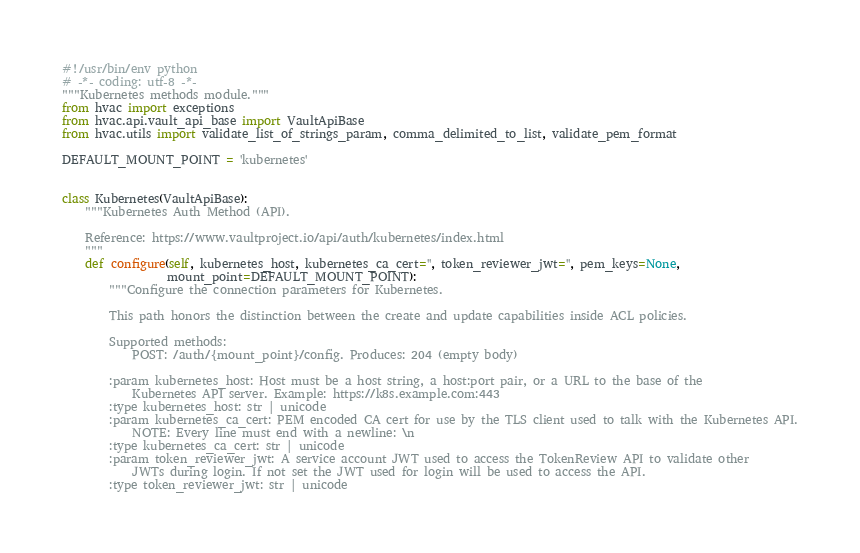<code> <loc_0><loc_0><loc_500><loc_500><_Python_>#!/usr/bin/env python
# -*- coding: utf-8 -*-
"""Kubernetes methods module."""
from hvac import exceptions
from hvac.api.vault_api_base import VaultApiBase
from hvac.utils import validate_list_of_strings_param, comma_delimited_to_list, validate_pem_format

DEFAULT_MOUNT_POINT = 'kubernetes'


class Kubernetes(VaultApiBase):
    """Kubernetes Auth Method (API).

    Reference: https://www.vaultproject.io/api/auth/kubernetes/index.html
    """
    def configure(self, kubernetes_host, kubernetes_ca_cert='', token_reviewer_jwt='', pem_keys=None,
                  mount_point=DEFAULT_MOUNT_POINT):
        """Configure the connection parameters for Kubernetes.

        This path honors the distinction between the create and update capabilities inside ACL policies.

        Supported methods:
            POST: /auth/{mount_point}/config. Produces: 204 (empty body)

        :param kubernetes_host: Host must be a host string, a host:port pair, or a URL to the base of the
            Kubernetes API server. Example: https://k8s.example.com:443
        :type kubernetes_host: str | unicode
        :param kubernetes_ca_cert: PEM encoded CA cert for use by the TLS client used to talk with the Kubernetes API.
            NOTE: Every line must end with a newline: \n
        :type kubernetes_ca_cert: str | unicode
        :param token_reviewer_jwt: A service account JWT used to access the TokenReview API to validate other
            JWTs during login. If not set the JWT used for login will be used to access the API.
        :type token_reviewer_jwt: str | unicode</code> 